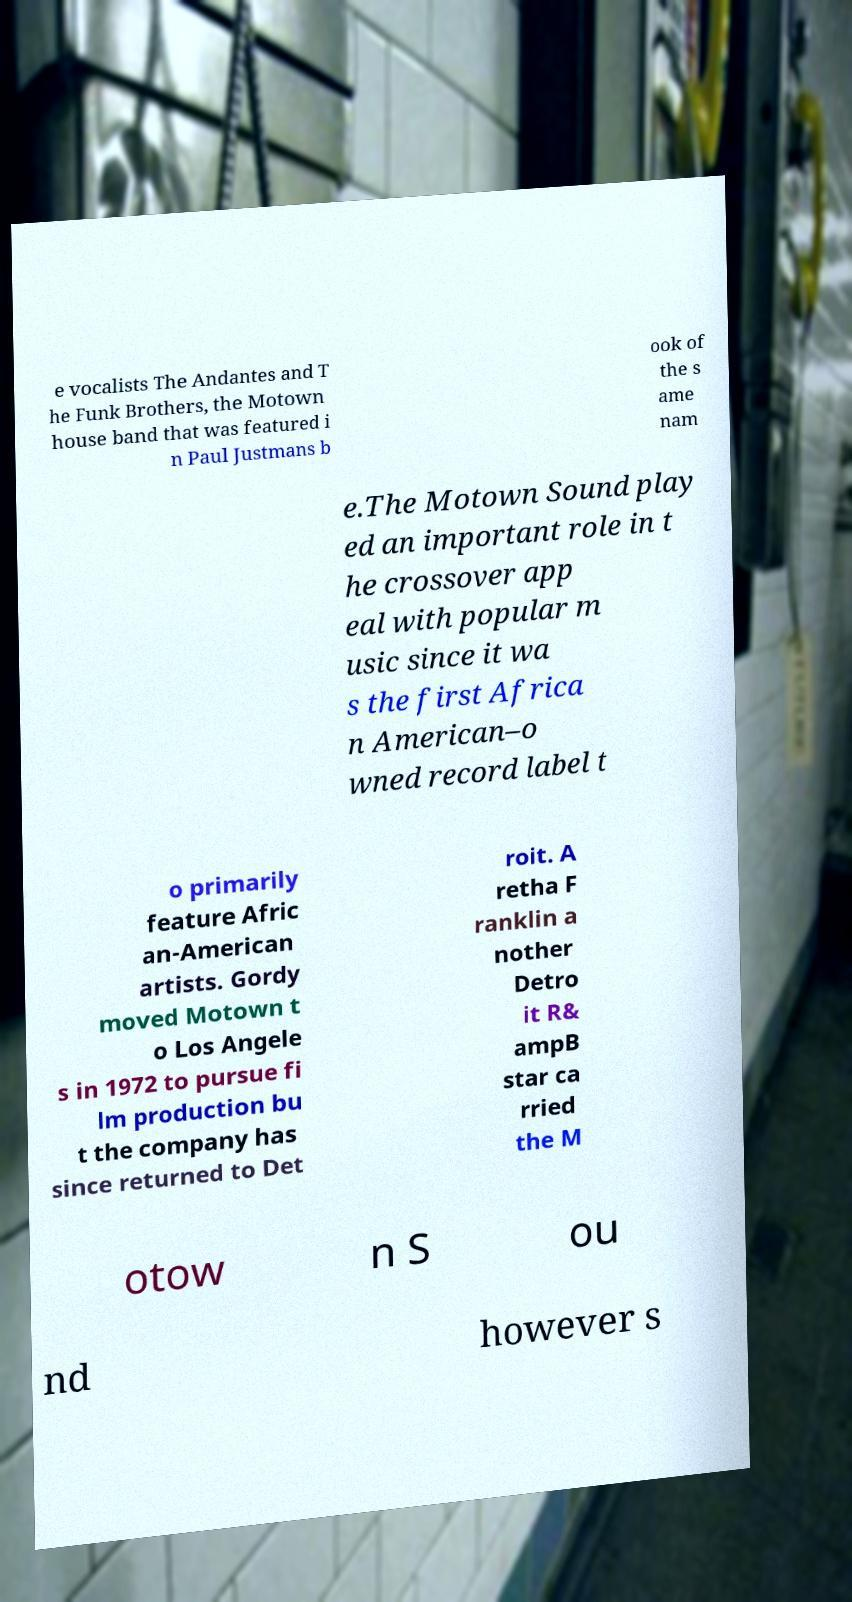I need the written content from this picture converted into text. Can you do that? e vocalists The Andantes and T he Funk Brothers, the Motown house band that was featured i n Paul Justmans b ook of the s ame nam e.The Motown Sound play ed an important role in t he crossover app eal with popular m usic since it wa s the first Africa n American–o wned record label t o primarily feature Afric an-American artists. Gordy moved Motown t o Los Angele s in 1972 to pursue fi lm production bu t the company has since returned to Det roit. A retha F ranklin a nother Detro it R& ampB star ca rried the M otow n S ou nd however s 